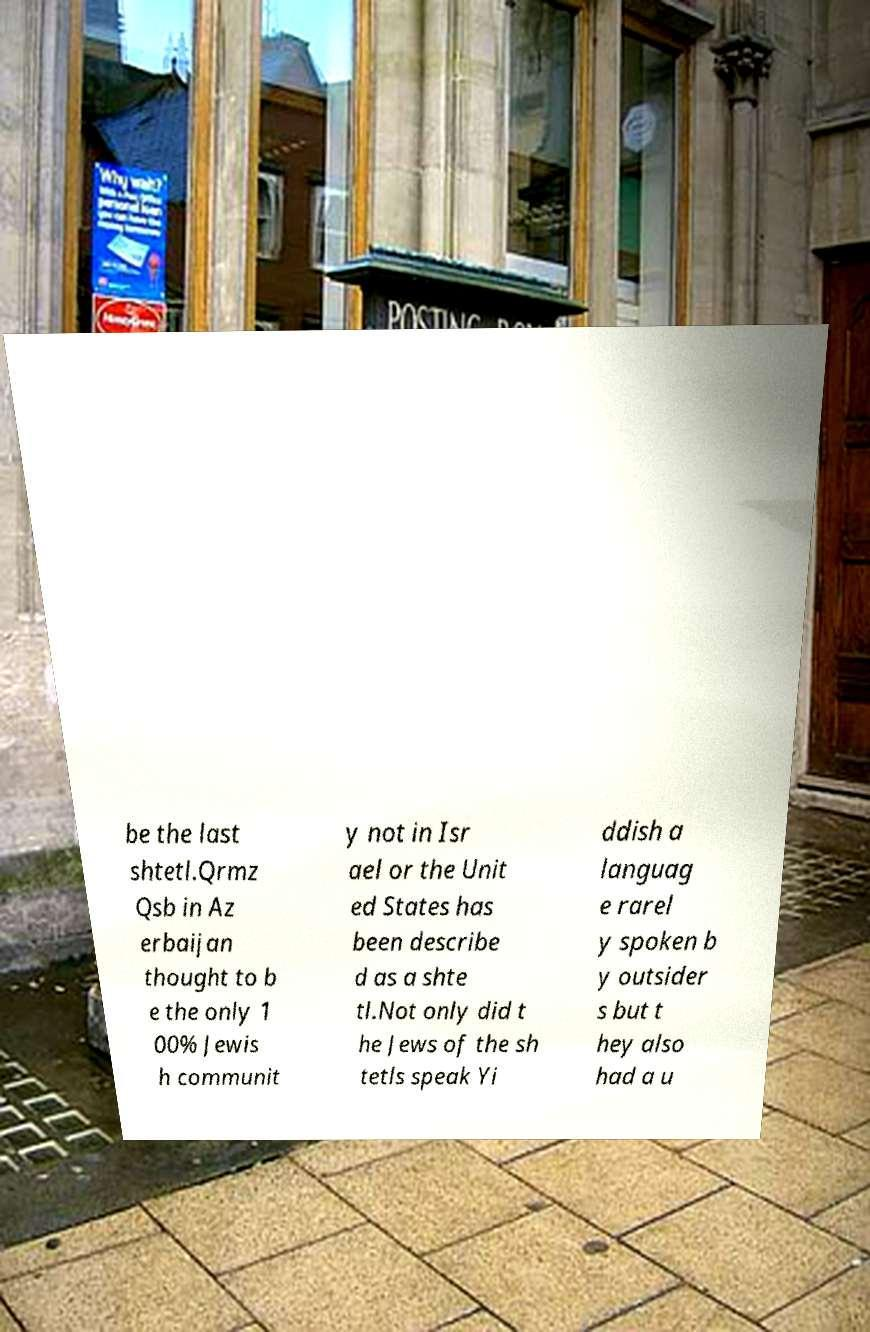Could you extract and type out the text from this image? be the last shtetl.Qrmz Qsb in Az erbaijan thought to b e the only 1 00% Jewis h communit y not in Isr ael or the Unit ed States has been describe d as a shte tl.Not only did t he Jews of the sh tetls speak Yi ddish a languag e rarel y spoken b y outsider s but t hey also had a u 